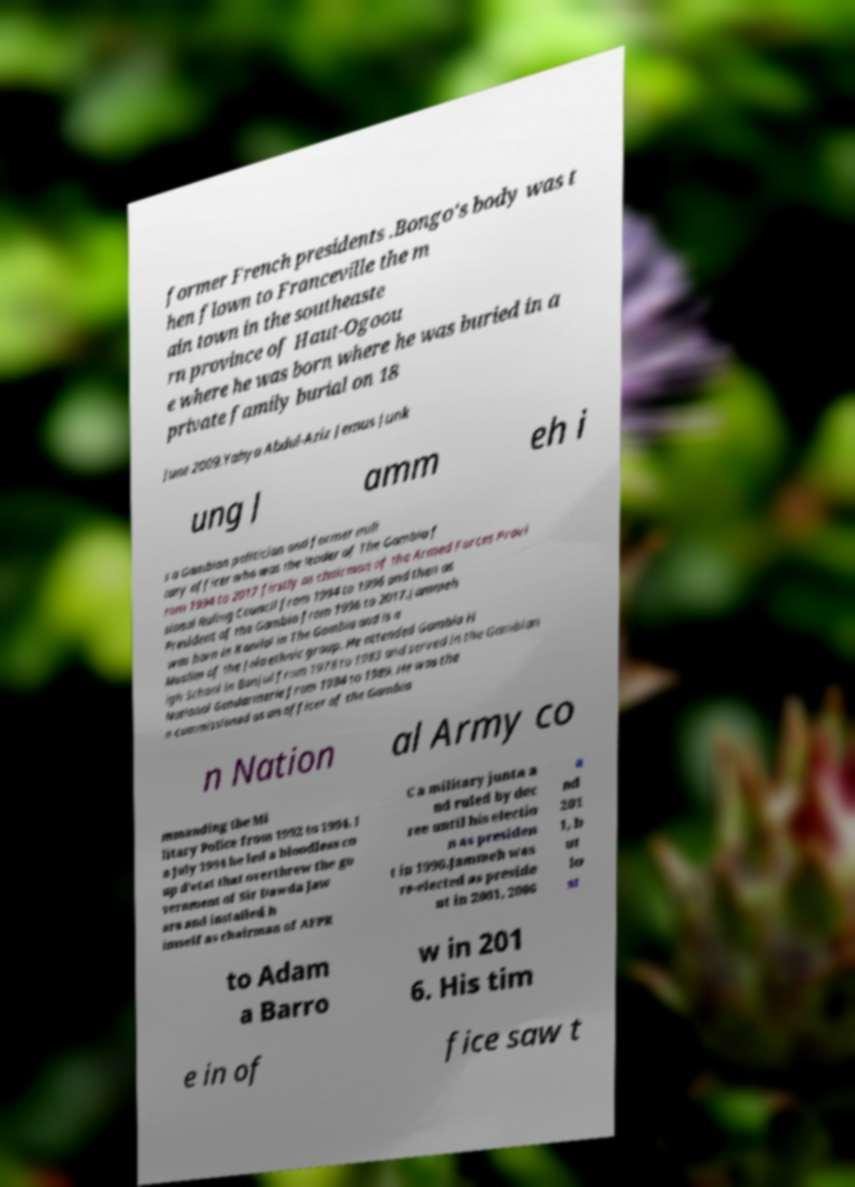Please read and relay the text visible in this image. What does it say? former French presidents .Bongo's body was t hen flown to Franceville the m ain town in the southeaste rn province of Haut-Ogoou e where he was born where he was buried in a private family burial on 18 June 2009.Yahya Abdul-Aziz Jemus Junk ung J amm eh i s a Gambian politician and former mili tary officer who was the leader of The Gambia f rom 1994 to 2017 firstly as chairman of the Armed Forces Provi sional Ruling Council from 1994 to 1996 and then as President of the Gambia from 1996 to 2017.Jammeh was born in Kanilai in The Gambia and is a Muslim of the Jola ethnic group. He attended Gambia H igh School in Banjul from 1978 to 1983 and served in the Gambian National Gendarmerie from 1984 to 1989. He was the n commissioned as an officer of the Gambia n Nation al Army co mmanding the Mi litary Police from 1992 to 1994. I n July 1994 he led a bloodless co up d'etat that overthrew the go vernment of Sir Dawda Jaw ara and installed h imself as chairman of AFPR C a military junta a nd ruled by dec ree until his electio n as presiden t in 1996.Jammeh was re-elected as preside nt in 2001, 2006 a nd 201 1, b ut lo st to Adam a Barro w in 201 6. His tim e in of fice saw t 